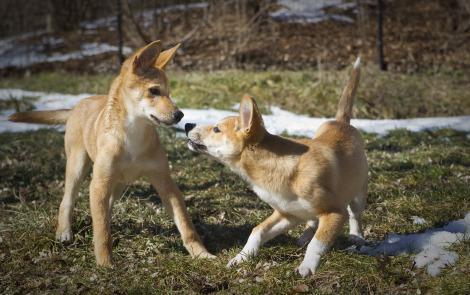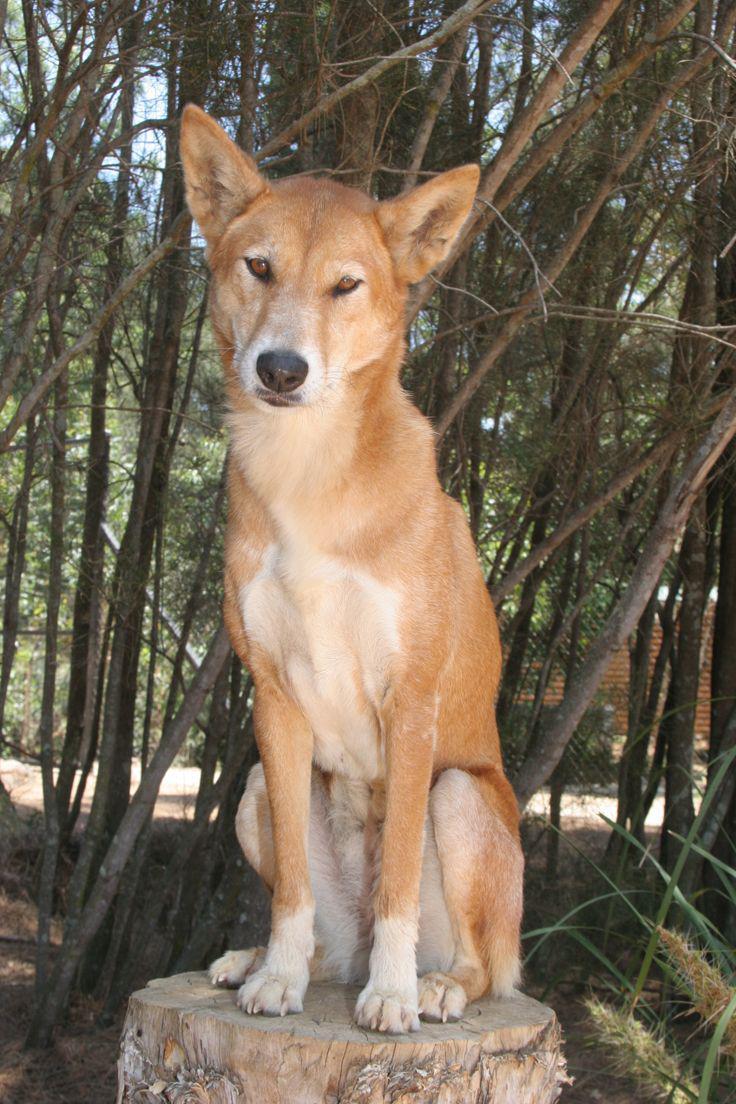The first image is the image on the left, the second image is the image on the right. For the images displayed, is the sentence "There are two animals in the image on the right." factually correct? Answer yes or no. No. 